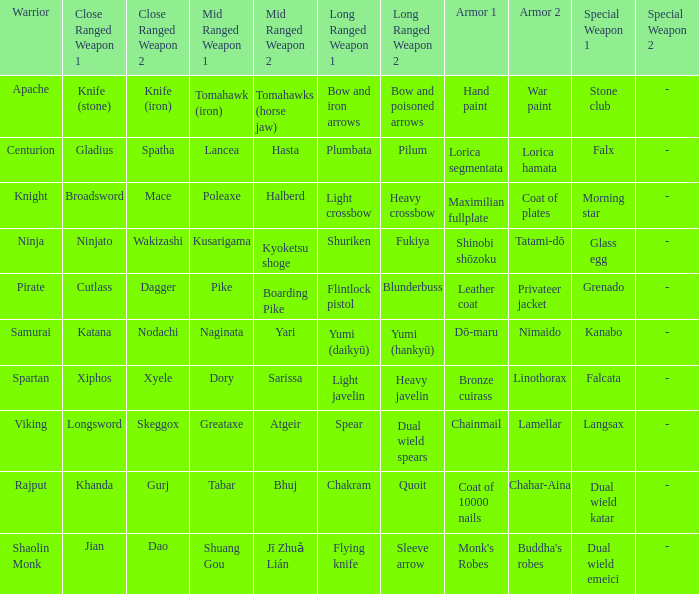If the armor is bronze cuirass , linothorax, what are the close ranged weapons? Xiphos , Xyele. 